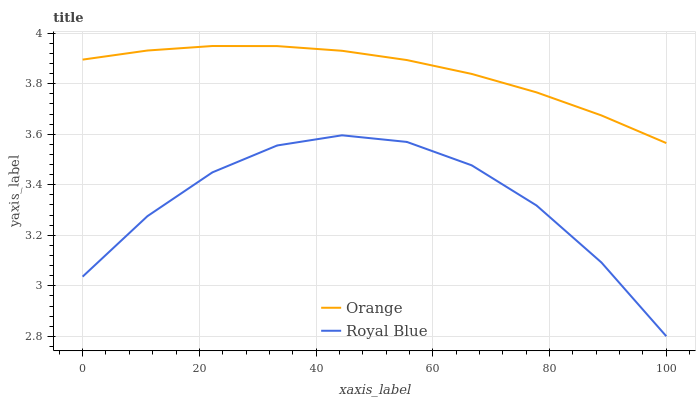Does Royal Blue have the minimum area under the curve?
Answer yes or no. Yes. Does Orange have the maximum area under the curve?
Answer yes or no. Yes. Does Royal Blue have the maximum area under the curve?
Answer yes or no. No. Is Orange the smoothest?
Answer yes or no. Yes. Is Royal Blue the roughest?
Answer yes or no. Yes. Is Royal Blue the smoothest?
Answer yes or no. No. Does Orange have the highest value?
Answer yes or no. Yes. Does Royal Blue have the highest value?
Answer yes or no. No. Is Royal Blue less than Orange?
Answer yes or no. Yes. Is Orange greater than Royal Blue?
Answer yes or no. Yes. Does Royal Blue intersect Orange?
Answer yes or no. No. 